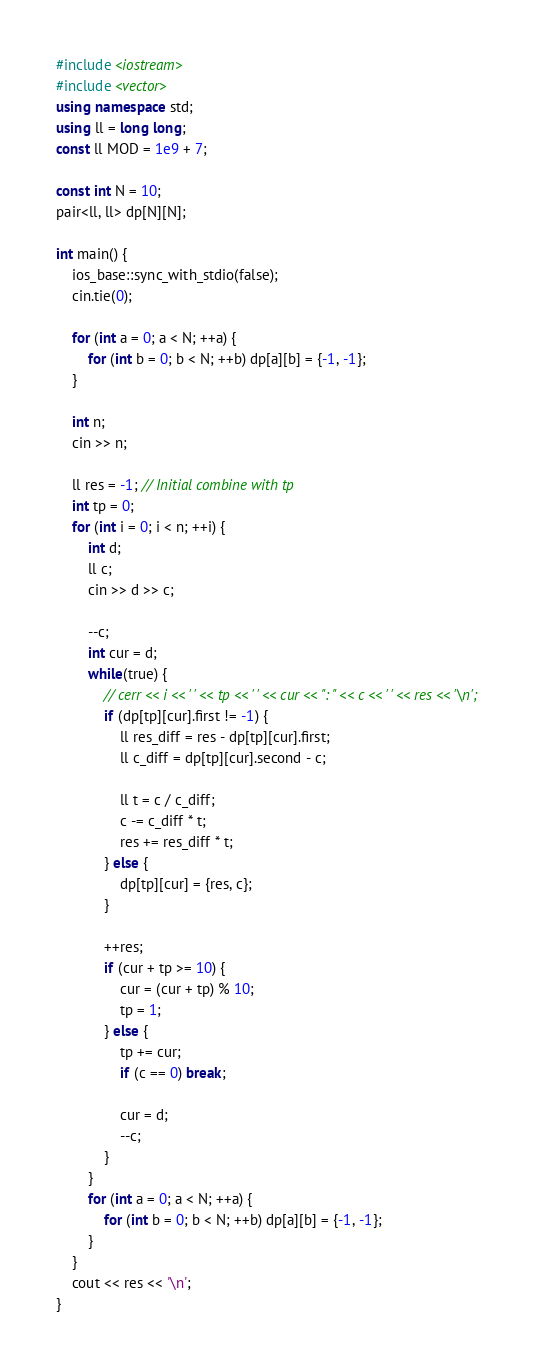<code> <loc_0><loc_0><loc_500><loc_500><_C++_>#include <iostream>
#include <vector>
using namespace std;
using ll = long long;
const ll MOD = 1e9 + 7;

const int N = 10;
pair<ll, ll> dp[N][N];

int main() {
	ios_base::sync_with_stdio(false);
	cin.tie(0);

	for (int a = 0; a < N; ++a) {
		for (int b = 0; b < N; ++b) dp[a][b] = {-1, -1};
	}

	int n;
	cin >> n;

	ll res = -1; // Initial combine with tp
	int tp = 0;
	for (int i = 0; i < n; ++i) {
		int d;
		ll c;
		cin >> d >> c;
		
		--c;
		int cur = d;
		while(true) {
			// cerr << i << ' ' << tp << ' ' << cur << ": " << c << ' ' << res << '\n';
			if (dp[tp][cur].first != -1) {
				ll res_diff = res - dp[tp][cur].first;
				ll c_diff = dp[tp][cur].second - c;

				ll t = c / c_diff;
				c -= c_diff * t;
				res += res_diff * t;
			} else {
				dp[tp][cur] = {res, c};
			}

			++res;
			if (cur + tp >= 10) {
				cur = (cur + tp) % 10;
				tp = 1;
			} else {
				tp += cur;
				if (c == 0) break;

				cur = d;
				--c;
			}
		}
		for (int a = 0; a < N; ++a) {
			for (int b = 0; b < N; ++b) dp[a][b] = {-1, -1};
		}
	}
	cout << res << '\n';
}
</code> 